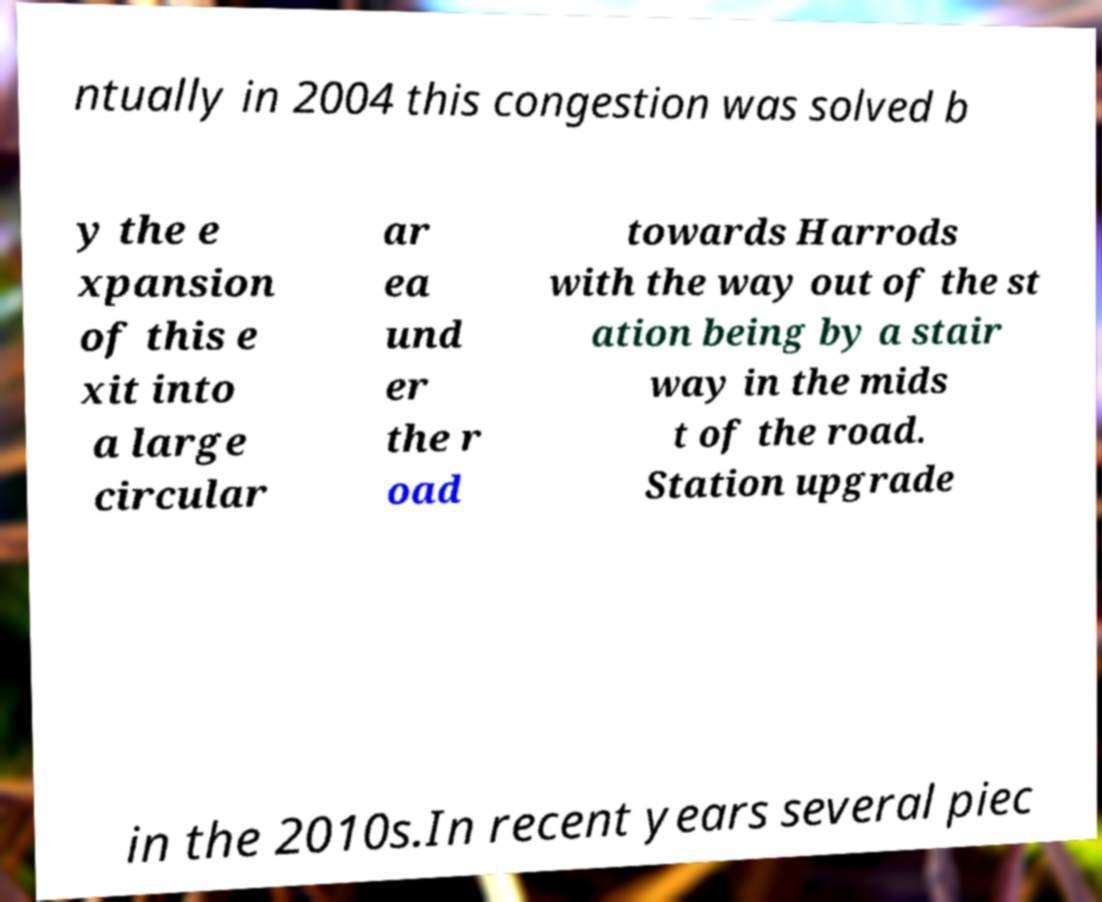What messages or text are displayed in this image? I need them in a readable, typed format. ntually in 2004 this congestion was solved b y the e xpansion of this e xit into a large circular ar ea und er the r oad towards Harrods with the way out of the st ation being by a stair way in the mids t of the road. Station upgrade in the 2010s.In recent years several piec 